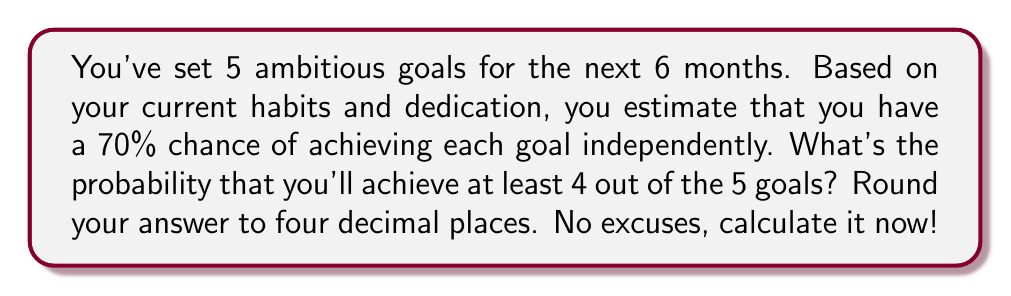Can you solve this math problem? Let's approach this step-by-step:

1) This is a binomial probability problem. We need to find P(X ≥ 4), where X is the number of successful goals.

2) The probability of success for each goal is p = 0.70, and the probability of failure is q = 1 - p = 0.30.

3) We need to calculate P(X = 4) + P(X = 5).

4) The formula for binomial probability is:

   $$P(X = k) = \binom{n}{k} p^k q^{n-k}$$

   where n is the total number of goals, and k is the number of successes.

5) For P(X = 4):
   $$P(X = 4) = \binom{5}{4} (0.70)^4 (0.30)^1$$
   $$= 5 \cdot 0.2401 \cdot 0.30 = 0.3602$$

6) For P(X = 5):
   $$P(X = 5) = \binom{5}{5} (0.70)^5 (0.30)^0$$
   $$= 1 \cdot 0.16807 \cdot 1 = 0.16807$$

7) Therefore, P(X ≥ 4) = P(X = 4) + P(X = 5) = 0.3602 + 0.16807 = 0.52827

8) Rounding to four decimal places: 0.5283
Answer: 0.5283 